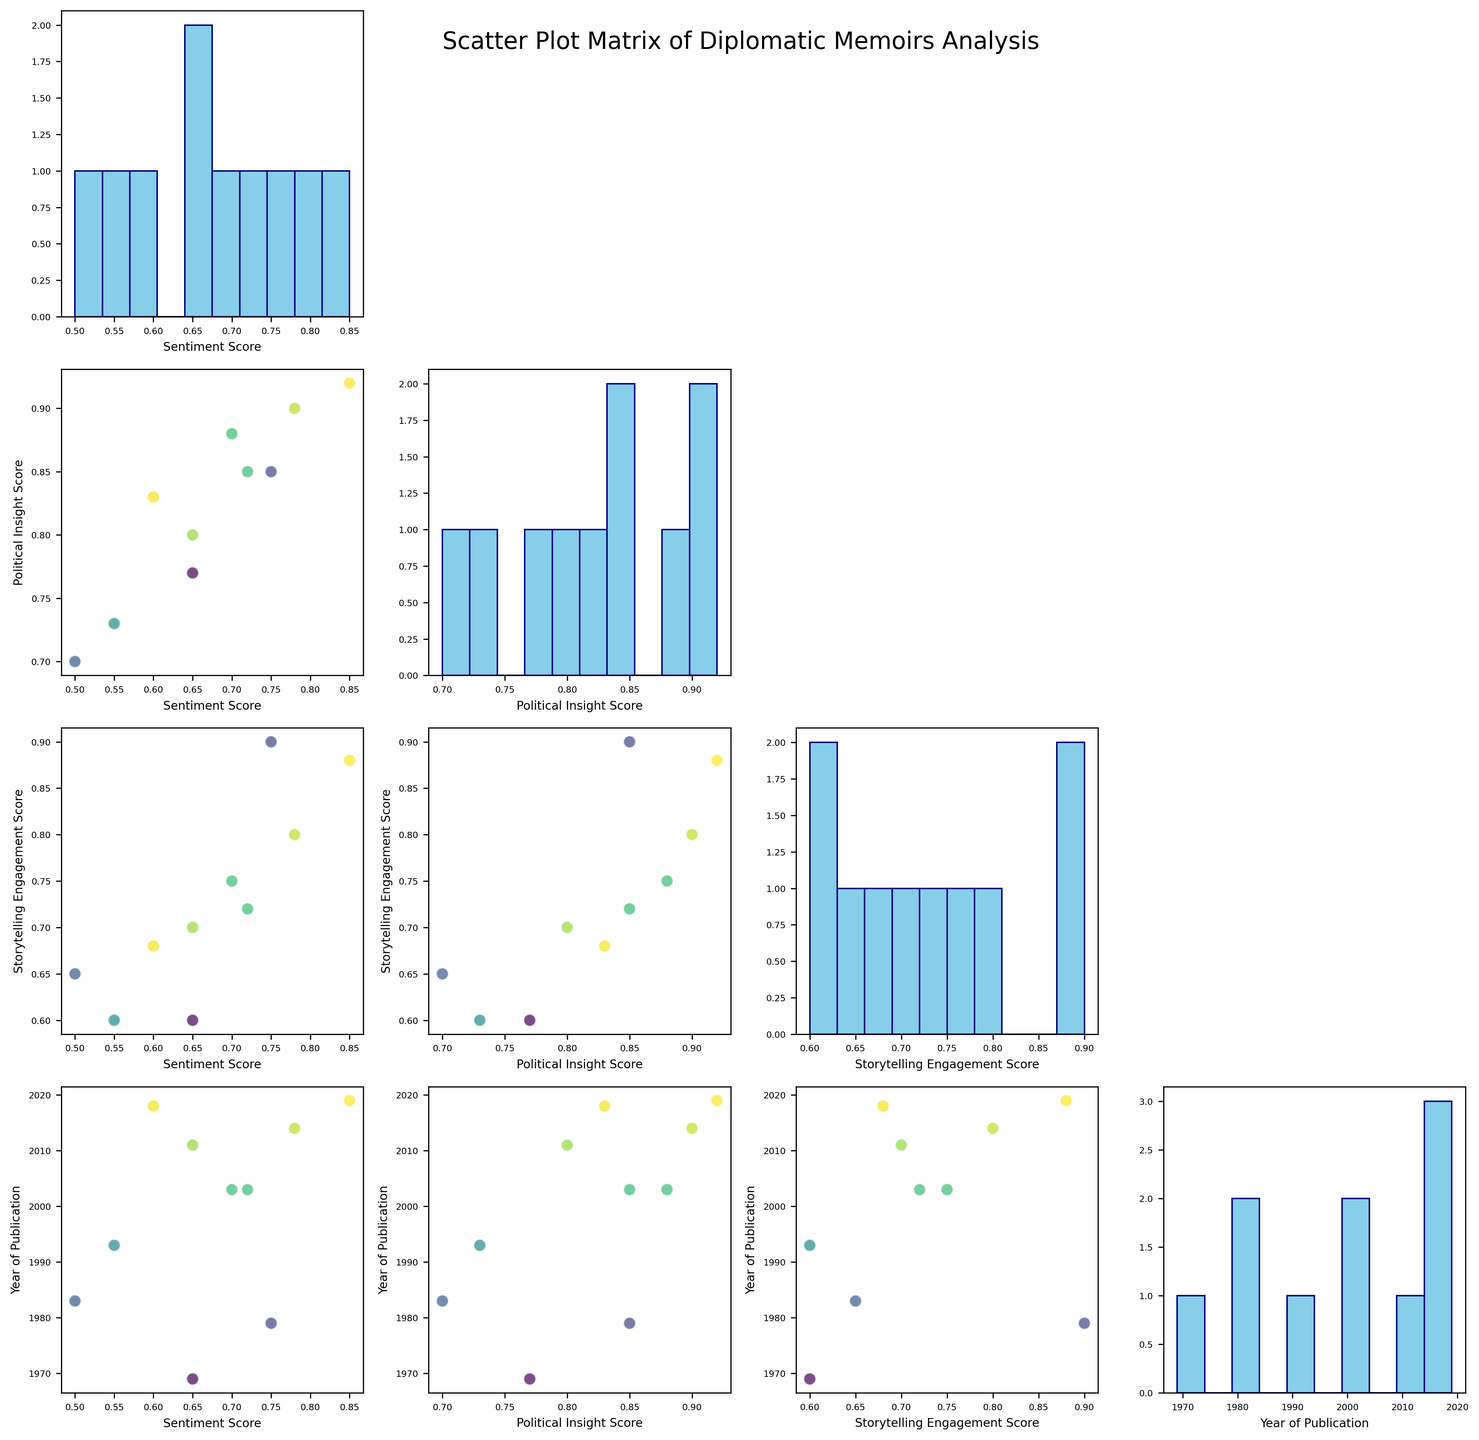What is the title of the figure? The title is generally placed at the top of the figure and is designed to provide a short description of what the figure is about.
Answer: Scatter Plot Matrix of Diplomatic Memoirs Analysis Which author has the highest Sentiment Score? To determine the highest Sentiment Score, look at the histogram of Sentiment Scores and find the author annotation at the highest score.
Answer: Samantha Power What is the range of publication years for the memoirs included in the figure? To find the range of publication years, look at the histogram of the Year of Publication and identify the earliest and the latest years.
Answer: 1969 to 2019 How many memoir passages were published after the year 2000? Identify data points in the scatter plots where the Year of Publication is greater than 2000 and count them.
Answer: 6 Which two authors have the closest Political Insight Scores? Compare the data points in the scatter plots for Political Insight Scores. Since there are authors with high and low scores, focus on those with close values.
Answer: Hillary Clinton and Samantha Power What is the average Storytelling Engagement Score of memoirs published before the year 2000? Filter the data points in the scatter plots to consider only those with the Year of Publication before 2000, then calculate the average of their Storytelling Engagement Scores.
Answer: 0.69 Which pair of features shows the strongest positive correlation in the scatter plot matrix? To identify the strongest positive correlation, look at the off-diagonal scatter plots and observe which pair exhibits a linear, upward trend.
Answer: Political Insight Score and Storytelling Engagement Score In which years were two memoirs published with identical Sentiment Scores of 0.70? Find the data points with the Sentiment Score of 0.70 and check their corresponding Year of Publication values to see if any year appears twice.
Answer: 2003 Is there any evident trend between Sentiment Score and Year of Publication? Observe the scatter plot of Sentiment Score versus Year of Publication to see if there's a consistent pattern, like an upward or downward trend, as the years progress.
Answer: No clear trend 